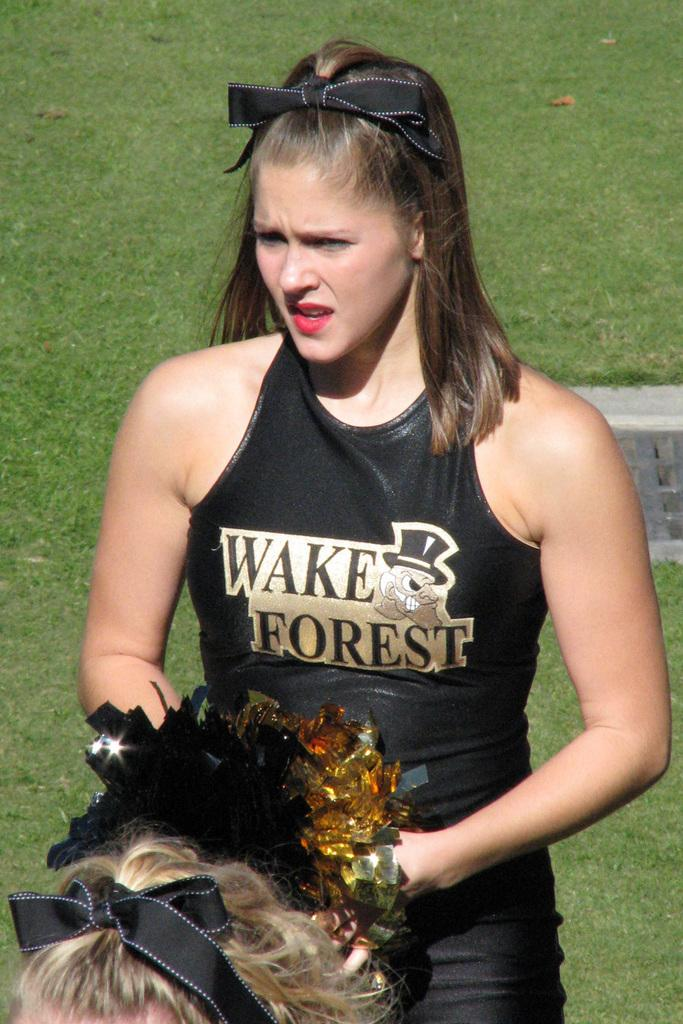<image>
Render a clear and concise summary of the photo. a lady that is wearing a wake forest cheering outfit 